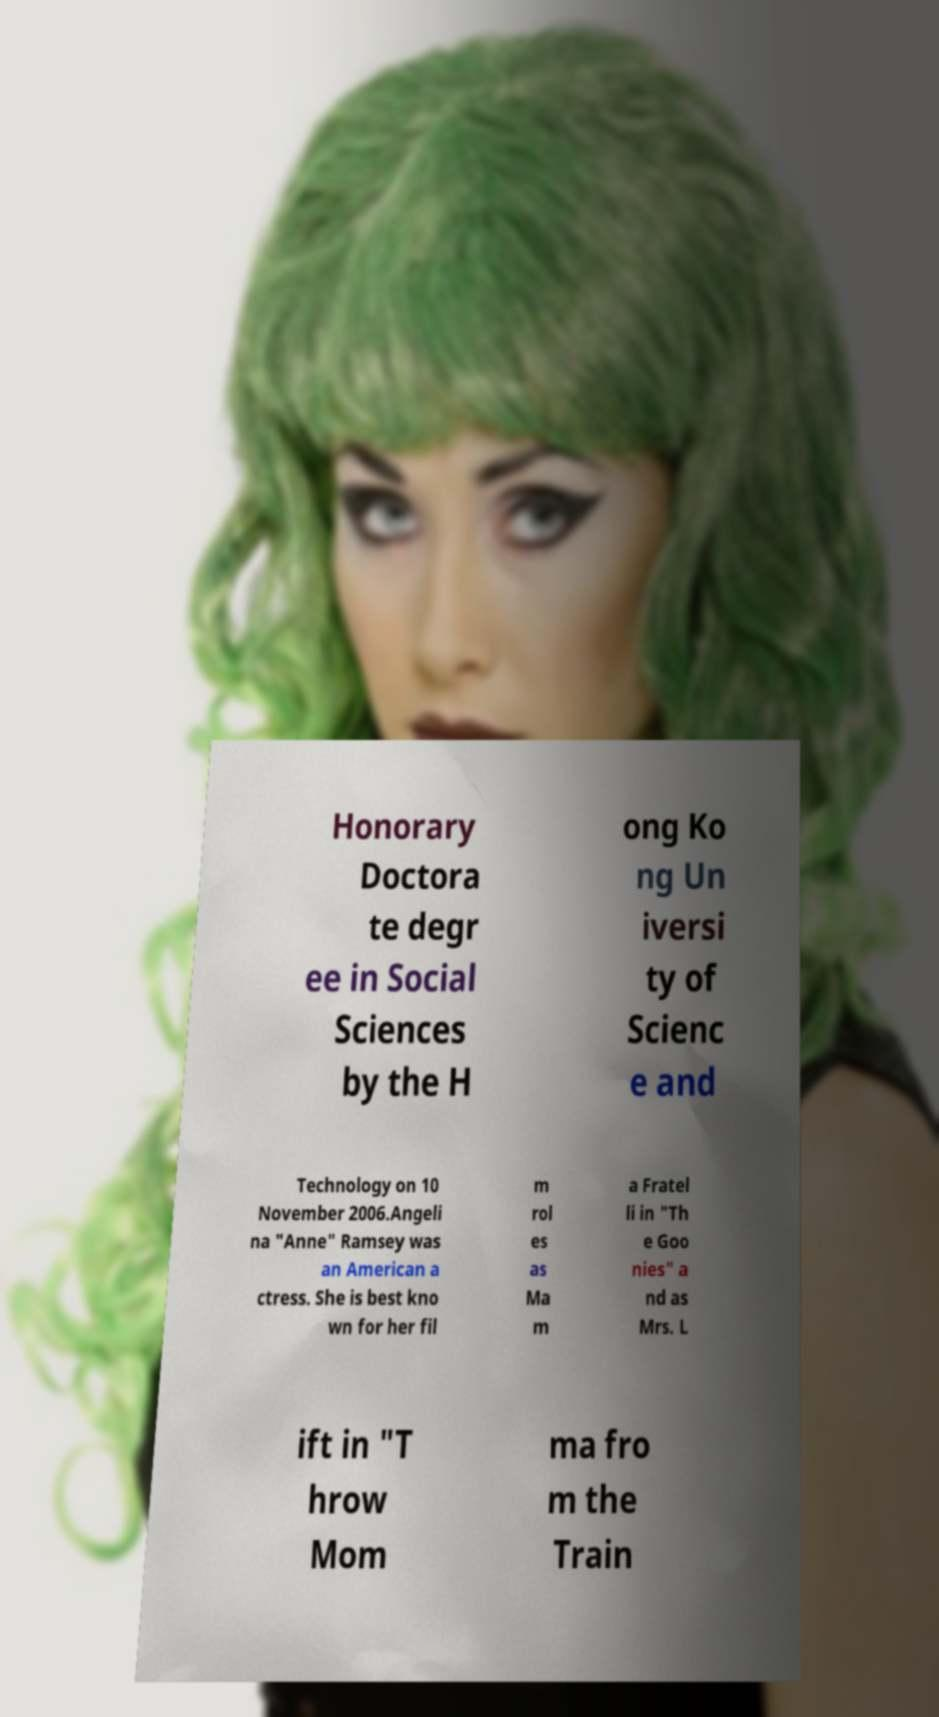What messages or text are displayed in this image? I need them in a readable, typed format. Honorary Doctora te degr ee in Social Sciences by the H ong Ko ng Un iversi ty of Scienc e and Technology on 10 November 2006.Angeli na "Anne" Ramsey was an American a ctress. She is best kno wn for her fil m rol es as Ma m a Fratel li in "Th e Goo nies" a nd as Mrs. L ift in "T hrow Mom ma fro m the Train 